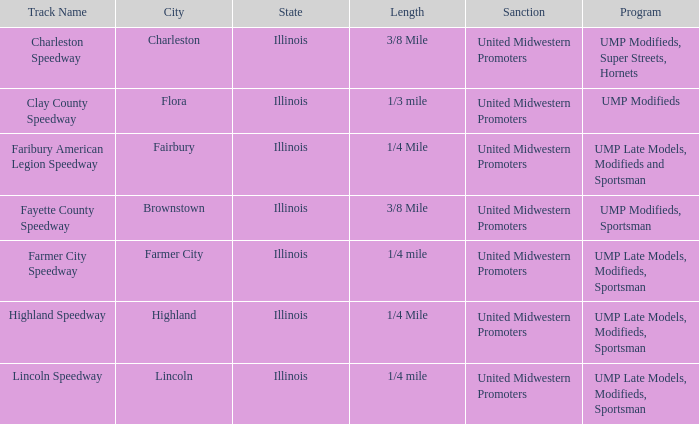What were the programs organized at highland speedway? UMP Late Models, Modifieds, Sportsman. 